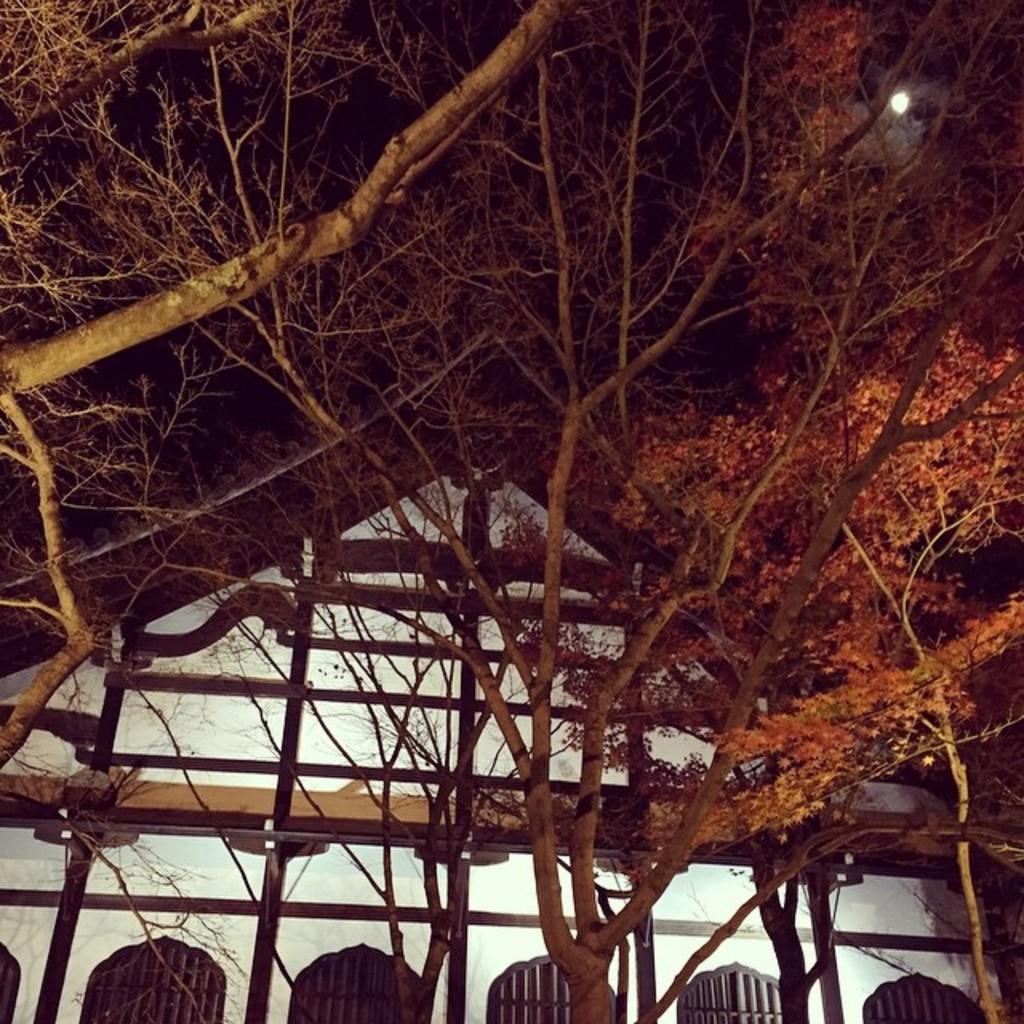Can you describe this image briefly? This is the picture of a building. In this image there is a building behind the trees. At the top there is sky and there is a moon. 